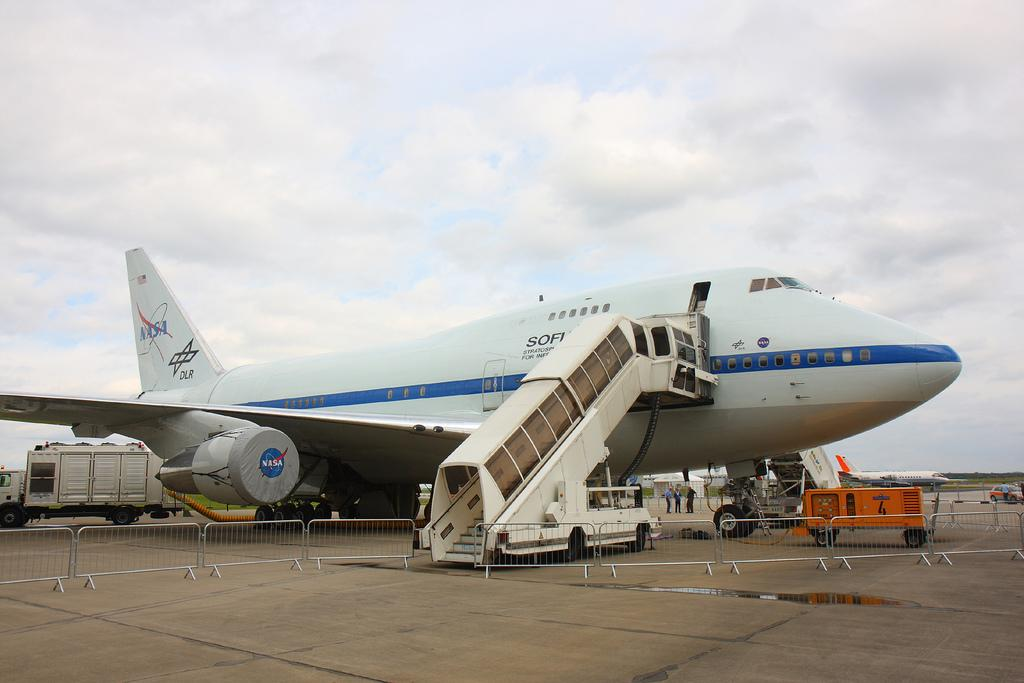What is located in the center of the image? There is a fence in the center of the image. What can be seen in the background of the image? There are airplanes, vehicles, and persons in the background of the image. What is the condition of the sky in the image? The sky is cloudy in the image. How many friends are sitting on the gate in the image? There is no gate or friends present in the image. What type of cars are visible in the image? There are no cars visible in the image; only airplanes and vehicles are mentioned. 